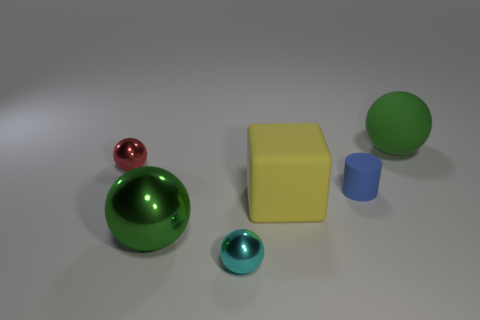Add 4 tiny things. How many objects exist? 10 Subtract all cubes. How many objects are left? 5 Add 4 large rubber spheres. How many large rubber spheres are left? 5 Add 1 large red objects. How many large red objects exist? 1 Subtract 0 cyan blocks. How many objects are left? 6 Subtract all big green metallic things. Subtract all blue rubber blocks. How many objects are left? 5 